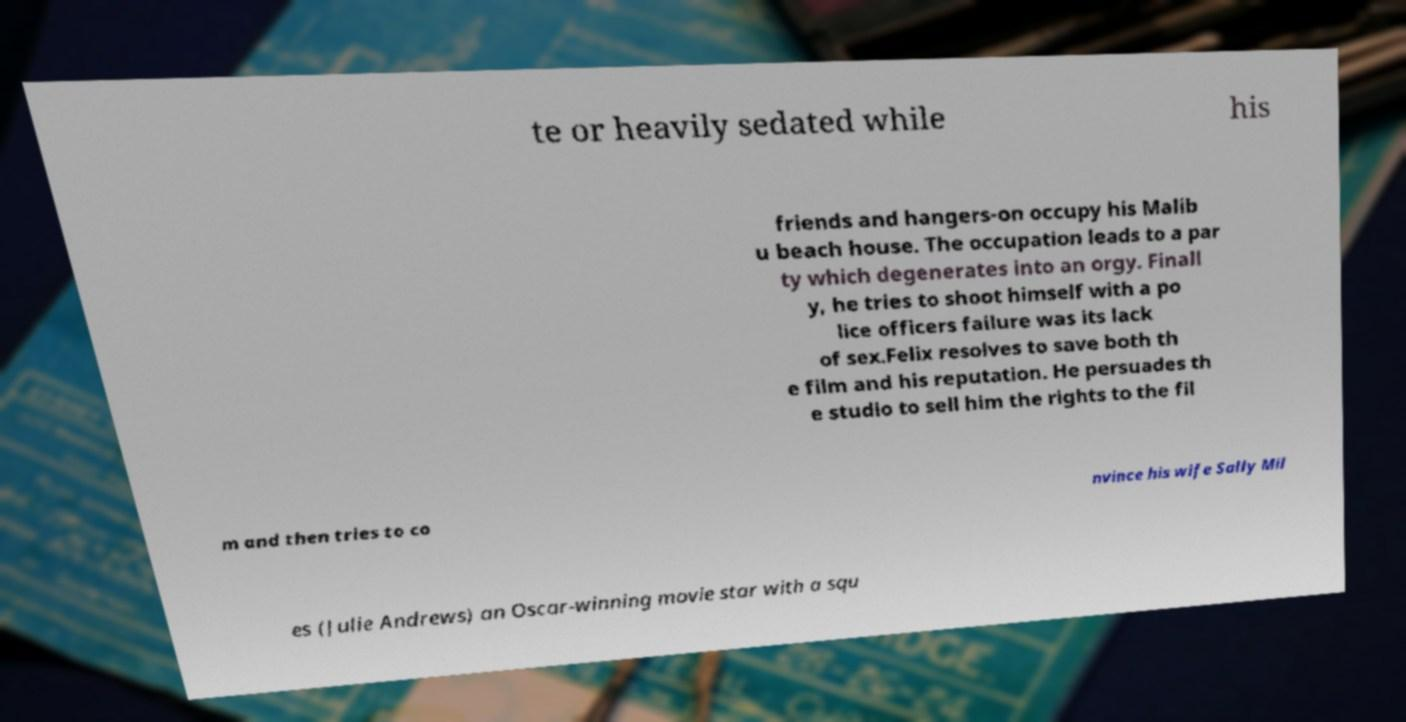I need the written content from this picture converted into text. Can you do that? te or heavily sedated while his friends and hangers-on occupy his Malib u beach house. The occupation leads to a par ty which degenerates into an orgy. Finall y, he tries to shoot himself with a po lice officers failure was its lack of sex.Felix resolves to save both th e film and his reputation. He persuades th e studio to sell him the rights to the fil m and then tries to co nvince his wife Sally Mil es (Julie Andrews) an Oscar-winning movie star with a squ 